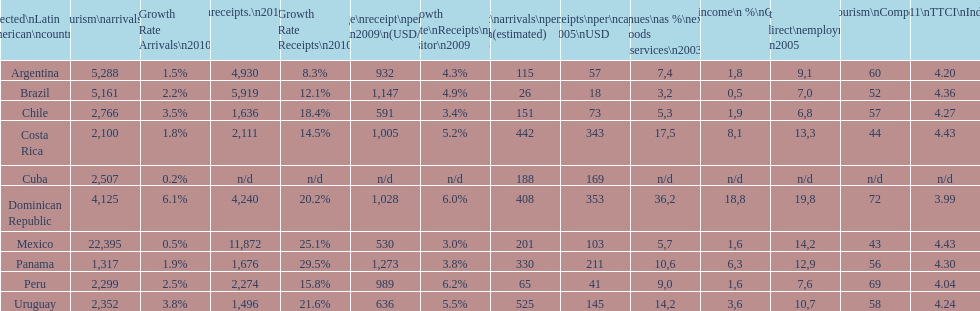What was the average amount of money received by brazil from each tourist in 2009? 1,147. 